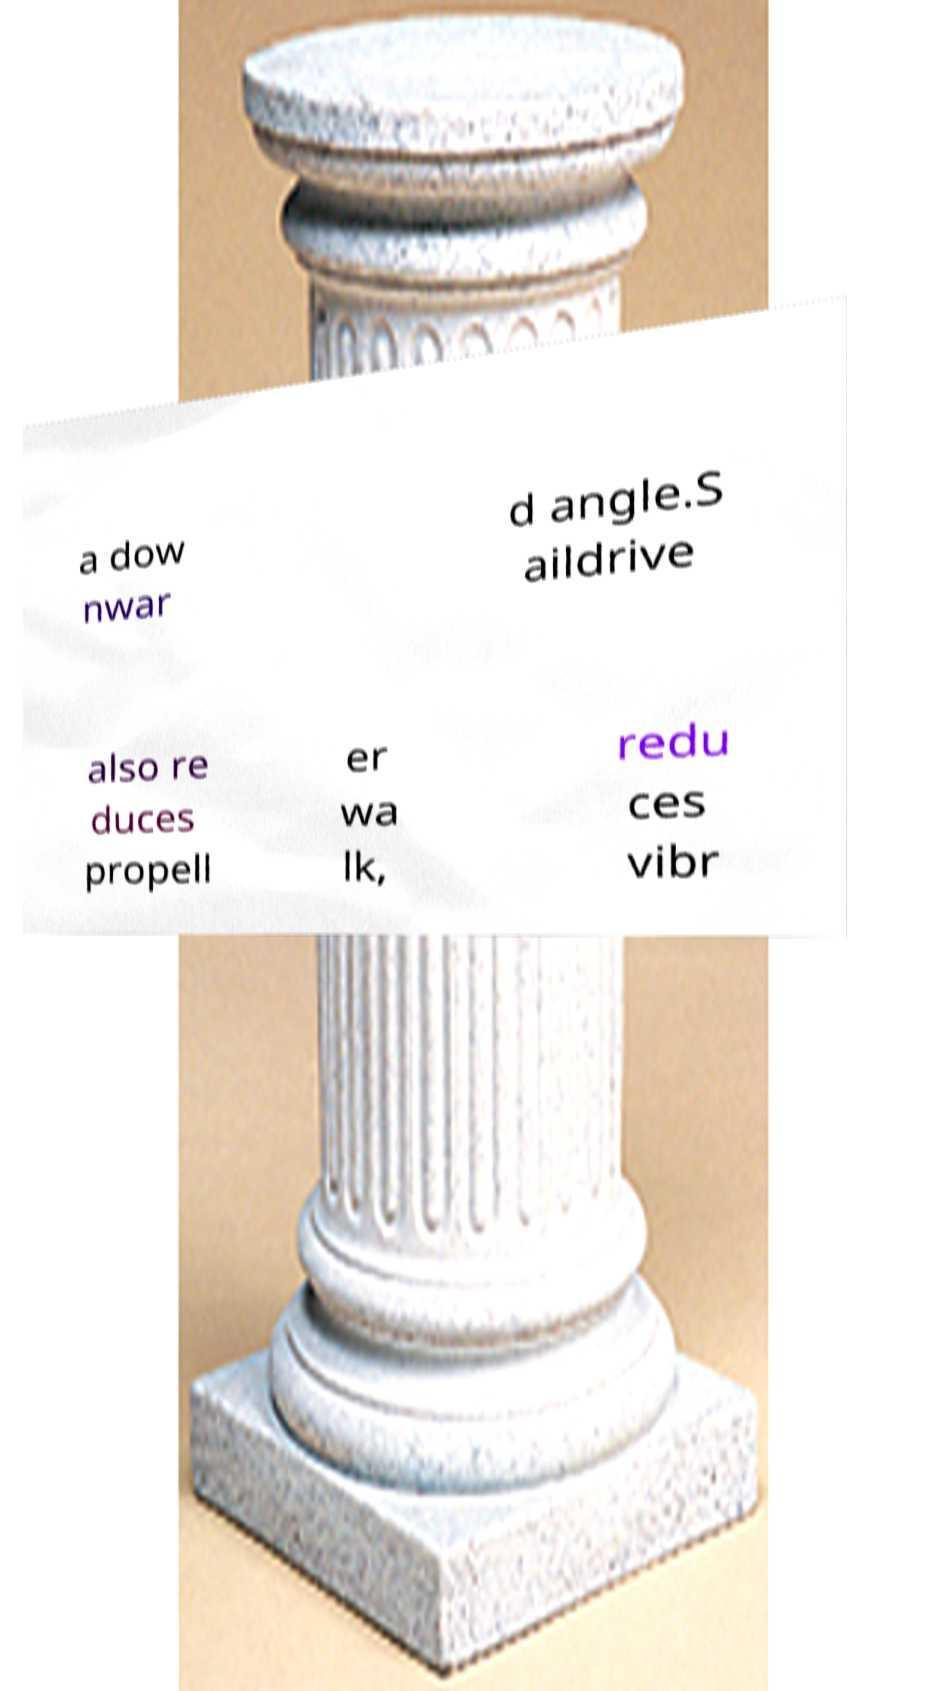What messages or text are displayed in this image? I need them in a readable, typed format. a dow nwar d angle.S aildrive also re duces propell er wa lk, redu ces vibr 